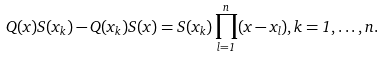Convert formula to latex. <formula><loc_0><loc_0><loc_500><loc_500>{ Q } ( x ) { S } ( { x } _ { k } ) - { Q } ( { x } _ { k } ) { S } ( x ) = { S } ( { x } _ { k } ) \prod _ { l = 1 } ^ { n } ( x - { x } _ { l } ) , k = 1 , \dots , n .</formula> 